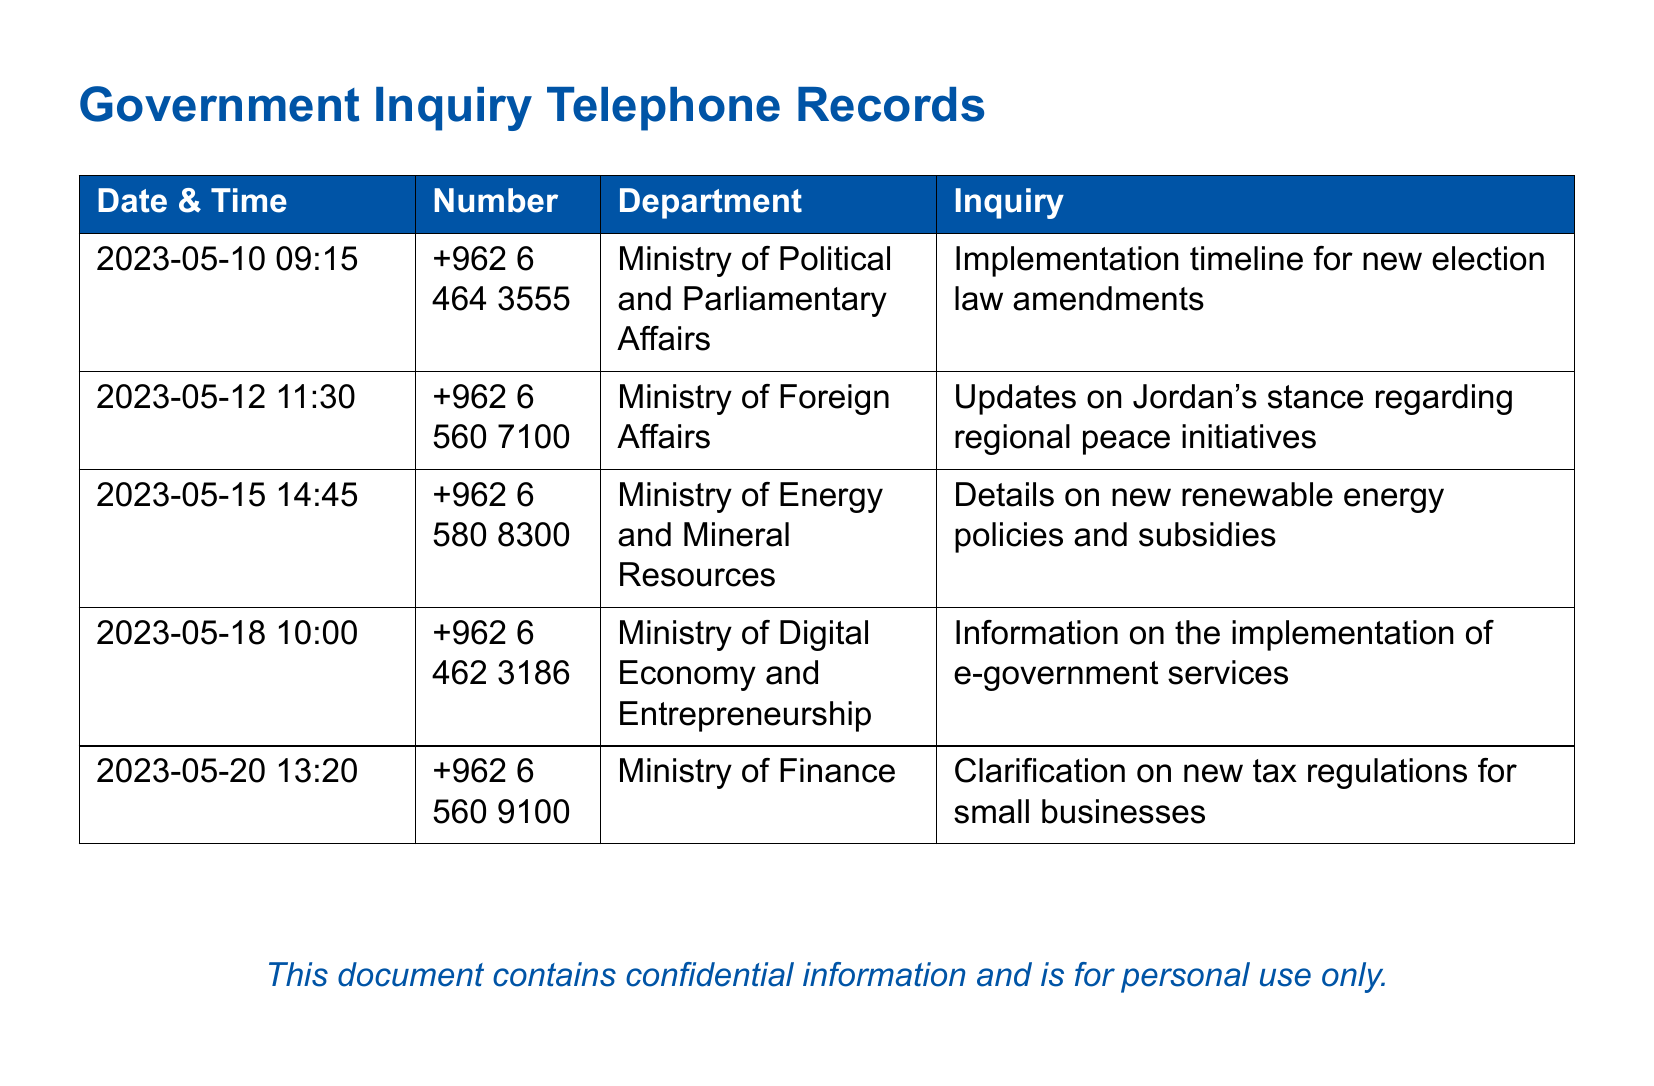what is the date of the inquiry about the new election law amendments? The date is listed in the first row of the table in the document, which is when the call was made regarding the election law amendments.
Answer: 2023-05-10 which ministry was contacted for updates on regional peace initiatives? The inquiry regarding regional peace initiatives was directed to a specific ministry, which is indicated in the second row of the table.
Answer: Ministry of Foreign Affairs how many inquiries were made on May 18, 2023? The document has an entry for May 18, which shows a single inquiry made on that date regarding e-government services.
Answer: 1 what type of policies were inquired about with the Ministry of Energy and Mineral Resources? The inquiry detailed in the document specifically pertains to renewable energy, as noted in the entry for that ministry.
Answer: Renewable energy policies and subsidies which department was asked for clarification on new tax regulations? The department associated with the inquiry about new tax regulations is outlined in the last row of the table in the document.
Answer: Ministry of Finance what was the time of the call regarding e-government services? The time can be found in the entry for May 18, which indicates when the inquiry about e-government services occurred.
Answer: 10:00 how many different ministries were contacted in total? The document lists inquiries to several different ministries, allowing for a count based on the unique entries provided.
Answer: 5 what was the primary subject of the inquiry made to the Ministry of Digital Economy and Entrepreneurship? The document specifies the subject related to the ministry, which can be found in the corresponding row of the table.
Answer: Implementation of e-government services 